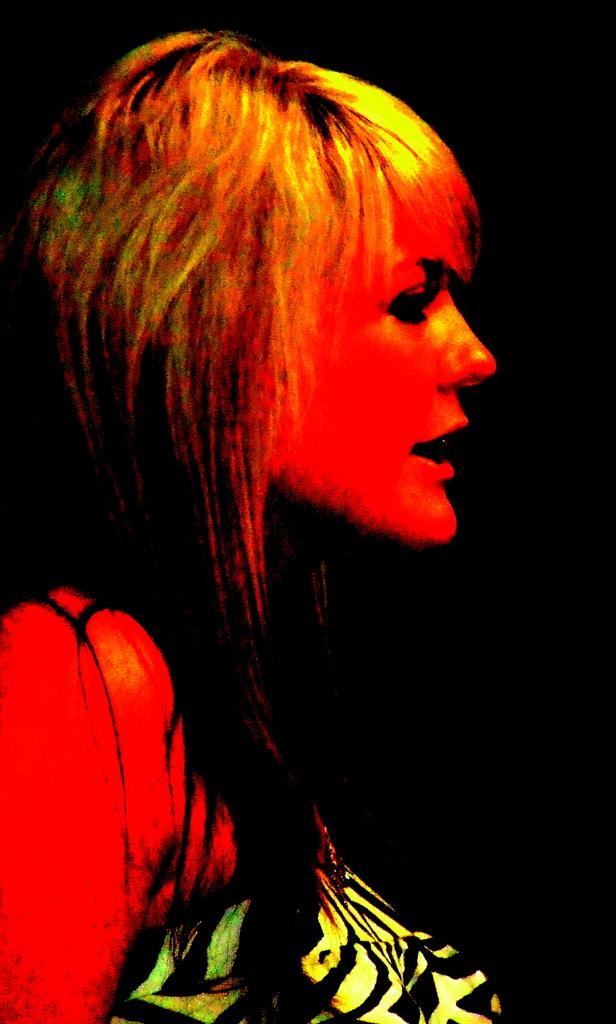Describe this image in one or two sentences. In the front of the image I can see a woman. In the background of the image it is dark. 